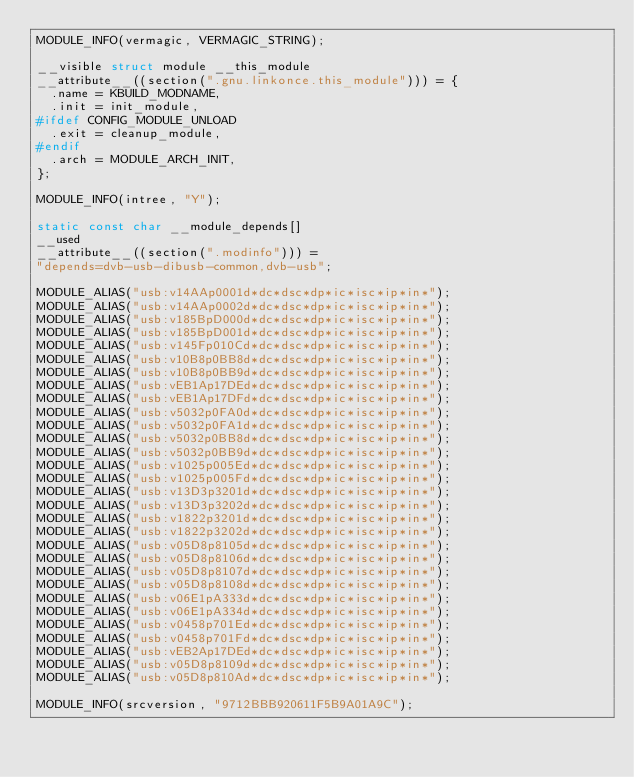Convert code to text. <code><loc_0><loc_0><loc_500><loc_500><_C_>MODULE_INFO(vermagic, VERMAGIC_STRING);

__visible struct module __this_module
__attribute__((section(".gnu.linkonce.this_module"))) = {
	.name = KBUILD_MODNAME,
	.init = init_module,
#ifdef CONFIG_MODULE_UNLOAD
	.exit = cleanup_module,
#endif
	.arch = MODULE_ARCH_INIT,
};

MODULE_INFO(intree, "Y");

static const char __module_depends[]
__used
__attribute__((section(".modinfo"))) =
"depends=dvb-usb-dibusb-common,dvb-usb";

MODULE_ALIAS("usb:v14AAp0001d*dc*dsc*dp*ic*isc*ip*in*");
MODULE_ALIAS("usb:v14AAp0002d*dc*dsc*dp*ic*isc*ip*in*");
MODULE_ALIAS("usb:v185BpD000d*dc*dsc*dp*ic*isc*ip*in*");
MODULE_ALIAS("usb:v185BpD001d*dc*dsc*dp*ic*isc*ip*in*");
MODULE_ALIAS("usb:v145Fp010Cd*dc*dsc*dp*ic*isc*ip*in*");
MODULE_ALIAS("usb:v10B8p0BB8d*dc*dsc*dp*ic*isc*ip*in*");
MODULE_ALIAS("usb:v10B8p0BB9d*dc*dsc*dp*ic*isc*ip*in*");
MODULE_ALIAS("usb:vEB1Ap17DEd*dc*dsc*dp*ic*isc*ip*in*");
MODULE_ALIAS("usb:vEB1Ap17DFd*dc*dsc*dp*ic*isc*ip*in*");
MODULE_ALIAS("usb:v5032p0FA0d*dc*dsc*dp*ic*isc*ip*in*");
MODULE_ALIAS("usb:v5032p0FA1d*dc*dsc*dp*ic*isc*ip*in*");
MODULE_ALIAS("usb:v5032p0BB8d*dc*dsc*dp*ic*isc*ip*in*");
MODULE_ALIAS("usb:v5032p0BB9d*dc*dsc*dp*ic*isc*ip*in*");
MODULE_ALIAS("usb:v1025p005Ed*dc*dsc*dp*ic*isc*ip*in*");
MODULE_ALIAS("usb:v1025p005Fd*dc*dsc*dp*ic*isc*ip*in*");
MODULE_ALIAS("usb:v13D3p3201d*dc*dsc*dp*ic*isc*ip*in*");
MODULE_ALIAS("usb:v13D3p3202d*dc*dsc*dp*ic*isc*ip*in*");
MODULE_ALIAS("usb:v1822p3201d*dc*dsc*dp*ic*isc*ip*in*");
MODULE_ALIAS("usb:v1822p3202d*dc*dsc*dp*ic*isc*ip*in*");
MODULE_ALIAS("usb:v05D8p8105d*dc*dsc*dp*ic*isc*ip*in*");
MODULE_ALIAS("usb:v05D8p8106d*dc*dsc*dp*ic*isc*ip*in*");
MODULE_ALIAS("usb:v05D8p8107d*dc*dsc*dp*ic*isc*ip*in*");
MODULE_ALIAS("usb:v05D8p8108d*dc*dsc*dp*ic*isc*ip*in*");
MODULE_ALIAS("usb:v06E1pA333d*dc*dsc*dp*ic*isc*ip*in*");
MODULE_ALIAS("usb:v06E1pA334d*dc*dsc*dp*ic*isc*ip*in*");
MODULE_ALIAS("usb:v0458p701Ed*dc*dsc*dp*ic*isc*ip*in*");
MODULE_ALIAS("usb:v0458p701Fd*dc*dsc*dp*ic*isc*ip*in*");
MODULE_ALIAS("usb:vEB2Ap17DEd*dc*dsc*dp*ic*isc*ip*in*");
MODULE_ALIAS("usb:v05D8p8109d*dc*dsc*dp*ic*isc*ip*in*");
MODULE_ALIAS("usb:v05D8p810Ad*dc*dsc*dp*ic*isc*ip*in*");

MODULE_INFO(srcversion, "9712BBB920611F5B9A01A9C");
</code> 